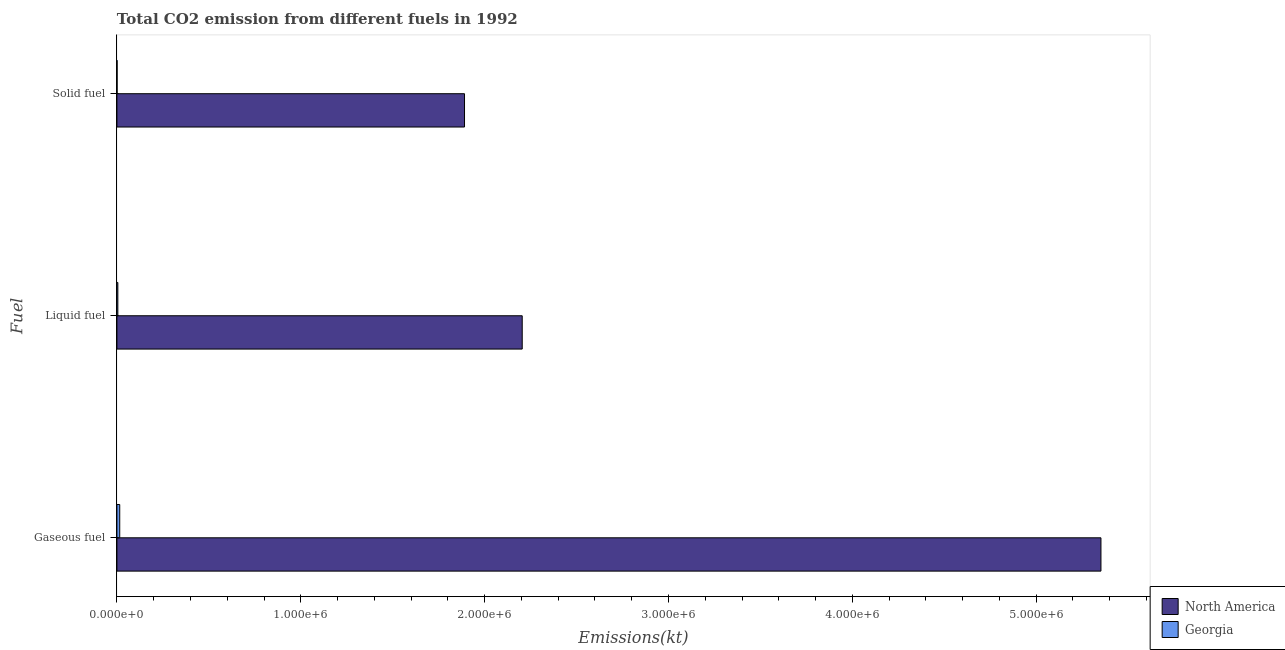How many different coloured bars are there?
Make the answer very short. 2. How many groups of bars are there?
Offer a terse response. 3. Are the number of bars per tick equal to the number of legend labels?
Your answer should be very brief. Yes. Are the number of bars on each tick of the Y-axis equal?
Your response must be concise. Yes. How many bars are there on the 1st tick from the bottom?
Offer a very short reply. 2. What is the label of the 3rd group of bars from the top?
Offer a terse response. Gaseous fuel. What is the amount of co2 emissions from liquid fuel in Georgia?
Make the answer very short. 5049.46. Across all countries, what is the maximum amount of co2 emissions from liquid fuel?
Give a very brief answer. 2.20e+06. Across all countries, what is the minimum amount of co2 emissions from solid fuel?
Give a very brief answer. 968.09. In which country was the amount of co2 emissions from solid fuel minimum?
Offer a very short reply. Georgia. What is the total amount of co2 emissions from gaseous fuel in the graph?
Make the answer very short. 5.37e+06. What is the difference between the amount of co2 emissions from liquid fuel in North America and that in Georgia?
Provide a succinct answer. 2.20e+06. What is the difference between the amount of co2 emissions from gaseous fuel in North America and the amount of co2 emissions from liquid fuel in Georgia?
Keep it short and to the point. 5.35e+06. What is the average amount of co2 emissions from solid fuel per country?
Provide a succinct answer. 9.46e+05. What is the difference between the amount of co2 emissions from liquid fuel and amount of co2 emissions from solid fuel in North America?
Offer a terse response. 3.14e+05. In how many countries, is the amount of co2 emissions from solid fuel greater than 4000000 kt?
Provide a short and direct response. 0. What is the ratio of the amount of co2 emissions from solid fuel in Georgia to that in North America?
Your response must be concise. 0. Is the difference between the amount of co2 emissions from gaseous fuel in North America and Georgia greater than the difference between the amount of co2 emissions from solid fuel in North America and Georgia?
Your answer should be compact. Yes. What is the difference between the highest and the second highest amount of co2 emissions from gaseous fuel?
Give a very brief answer. 5.34e+06. What is the difference between the highest and the lowest amount of co2 emissions from liquid fuel?
Your answer should be compact. 2.20e+06. In how many countries, is the amount of co2 emissions from solid fuel greater than the average amount of co2 emissions from solid fuel taken over all countries?
Provide a short and direct response. 1. Is the sum of the amount of co2 emissions from gaseous fuel in Georgia and North America greater than the maximum amount of co2 emissions from liquid fuel across all countries?
Your response must be concise. Yes. What does the 1st bar from the top in Liquid fuel represents?
Give a very brief answer. Georgia. What does the 2nd bar from the bottom in Gaseous fuel represents?
Offer a very short reply. Georgia. Are all the bars in the graph horizontal?
Provide a succinct answer. Yes. What is the difference between two consecutive major ticks on the X-axis?
Provide a succinct answer. 1.00e+06. Does the graph contain any zero values?
Give a very brief answer. No. Where does the legend appear in the graph?
Your answer should be compact. Bottom right. How many legend labels are there?
Keep it short and to the point. 2. How are the legend labels stacked?
Offer a very short reply. Vertical. What is the title of the graph?
Provide a succinct answer. Total CO2 emission from different fuels in 1992. Does "Latvia" appear as one of the legend labels in the graph?
Give a very brief answer. No. What is the label or title of the X-axis?
Ensure brevity in your answer.  Emissions(kt). What is the label or title of the Y-axis?
Your response must be concise. Fuel. What is the Emissions(kt) of North America in Gaseous fuel?
Your answer should be very brief. 5.35e+06. What is the Emissions(kt) in Georgia in Gaseous fuel?
Your answer should be very brief. 1.53e+04. What is the Emissions(kt) of North America in Liquid fuel?
Keep it short and to the point. 2.20e+06. What is the Emissions(kt) in Georgia in Liquid fuel?
Give a very brief answer. 5049.46. What is the Emissions(kt) of North America in Solid fuel?
Provide a short and direct response. 1.89e+06. What is the Emissions(kt) of Georgia in Solid fuel?
Keep it short and to the point. 968.09. Across all Fuel, what is the maximum Emissions(kt) in North America?
Provide a succinct answer. 5.35e+06. Across all Fuel, what is the maximum Emissions(kt) in Georgia?
Offer a terse response. 1.53e+04. Across all Fuel, what is the minimum Emissions(kt) in North America?
Ensure brevity in your answer.  1.89e+06. Across all Fuel, what is the minimum Emissions(kt) of Georgia?
Your response must be concise. 968.09. What is the total Emissions(kt) of North America in the graph?
Offer a very short reply. 9.45e+06. What is the total Emissions(kt) in Georgia in the graph?
Give a very brief answer. 2.14e+04. What is the difference between the Emissions(kt) of North America in Gaseous fuel and that in Liquid fuel?
Your response must be concise. 3.15e+06. What is the difference between the Emissions(kt) in Georgia in Gaseous fuel and that in Liquid fuel?
Your response must be concise. 1.03e+04. What is the difference between the Emissions(kt) of North America in Gaseous fuel and that in Solid fuel?
Provide a short and direct response. 3.46e+06. What is the difference between the Emissions(kt) in Georgia in Gaseous fuel and that in Solid fuel?
Your answer should be compact. 1.44e+04. What is the difference between the Emissions(kt) of North America in Liquid fuel and that in Solid fuel?
Provide a succinct answer. 3.14e+05. What is the difference between the Emissions(kt) in Georgia in Liquid fuel and that in Solid fuel?
Offer a terse response. 4081.37. What is the difference between the Emissions(kt) in North America in Gaseous fuel and the Emissions(kt) in Georgia in Liquid fuel?
Offer a terse response. 5.35e+06. What is the difference between the Emissions(kt) in North America in Gaseous fuel and the Emissions(kt) in Georgia in Solid fuel?
Ensure brevity in your answer.  5.35e+06. What is the difference between the Emissions(kt) in North America in Liquid fuel and the Emissions(kt) in Georgia in Solid fuel?
Give a very brief answer. 2.20e+06. What is the average Emissions(kt) in North America per Fuel?
Offer a terse response. 3.15e+06. What is the average Emissions(kt) of Georgia per Fuel?
Your answer should be very brief. 7117.65. What is the difference between the Emissions(kt) in North America and Emissions(kt) in Georgia in Gaseous fuel?
Your response must be concise. 5.34e+06. What is the difference between the Emissions(kt) in North America and Emissions(kt) in Georgia in Liquid fuel?
Your response must be concise. 2.20e+06. What is the difference between the Emissions(kt) in North America and Emissions(kt) in Georgia in Solid fuel?
Offer a terse response. 1.89e+06. What is the ratio of the Emissions(kt) in North America in Gaseous fuel to that in Liquid fuel?
Keep it short and to the point. 2.43. What is the ratio of the Emissions(kt) of Georgia in Gaseous fuel to that in Liquid fuel?
Provide a succinct answer. 3.04. What is the ratio of the Emissions(kt) of North America in Gaseous fuel to that in Solid fuel?
Your answer should be very brief. 2.83. What is the ratio of the Emissions(kt) of Georgia in Gaseous fuel to that in Solid fuel?
Your answer should be compact. 15.84. What is the ratio of the Emissions(kt) of North America in Liquid fuel to that in Solid fuel?
Keep it short and to the point. 1.17. What is the ratio of the Emissions(kt) of Georgia in Liquid fuel to that in Solid fuel?
Make the answer very short. 5.22. What is the difference between the highest and the second highest Emissions(kt) in North America?
Offer a terse response. 3.15e+06. What is the difference between the highest and the second highest Emissions(kt) of Georgia?
Offer a terse response. 1.03e+04. What is the difference between the highest and the lowest Emissions(kt) of North America?
Provide a succinct answer. 3.46e+06. What is the difference between the highest and the lowest Emissions(kt) of Georgia?
Provide a short and direct response. 1.44e+04. 